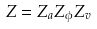<formula> <loc_0><loc_0><loc_500><loc_500>Z = Z _ { a } Z _ { \phi } Z _ { v }</formula> 